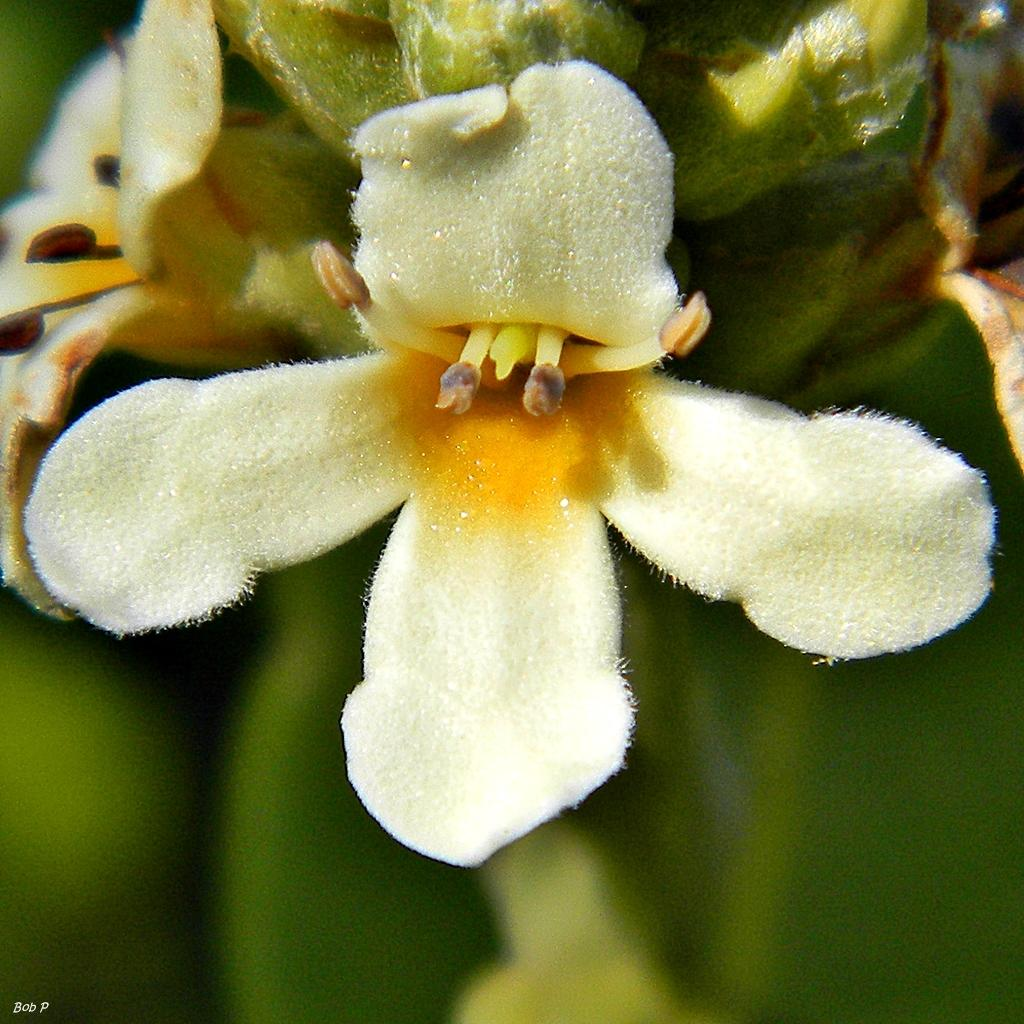What type of living organisms can be seen in the image? There are flowers in the image. How would you describe the background of the image? The background of the image is blurry. Is there any text present in the image? Yes, there is some text in the bottom left corner of the image. What type of metal is used to create the flowers in the image? There is no metal used to create the flowers in the image; they are living organisms. 